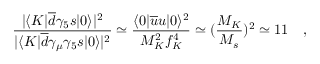Convert formula to latex. <formula><loc_0><loc_0><loc_500><loc_500>{ \frac { | \langle K | \overline { d } \gamma _ { 5 } s | 0 \rangle | ^ { 2 } } { | \langle K | \overline { d } \gamma _ { \mu } \gamma _ { 5 } s | 0 \rangle | ^ { 2 } } } \simeq { \frac { \langle 0 | \overline { u } u | 0 \rangle ^ { 2 } } { M _ { K } ^ { 2 } f _ { K } ^ { 4 } } } \simeq ( { \frac { M _ { K } } { M _ { s } } } ) ^ { 2 } \simeq 1 1 ,</formula> 